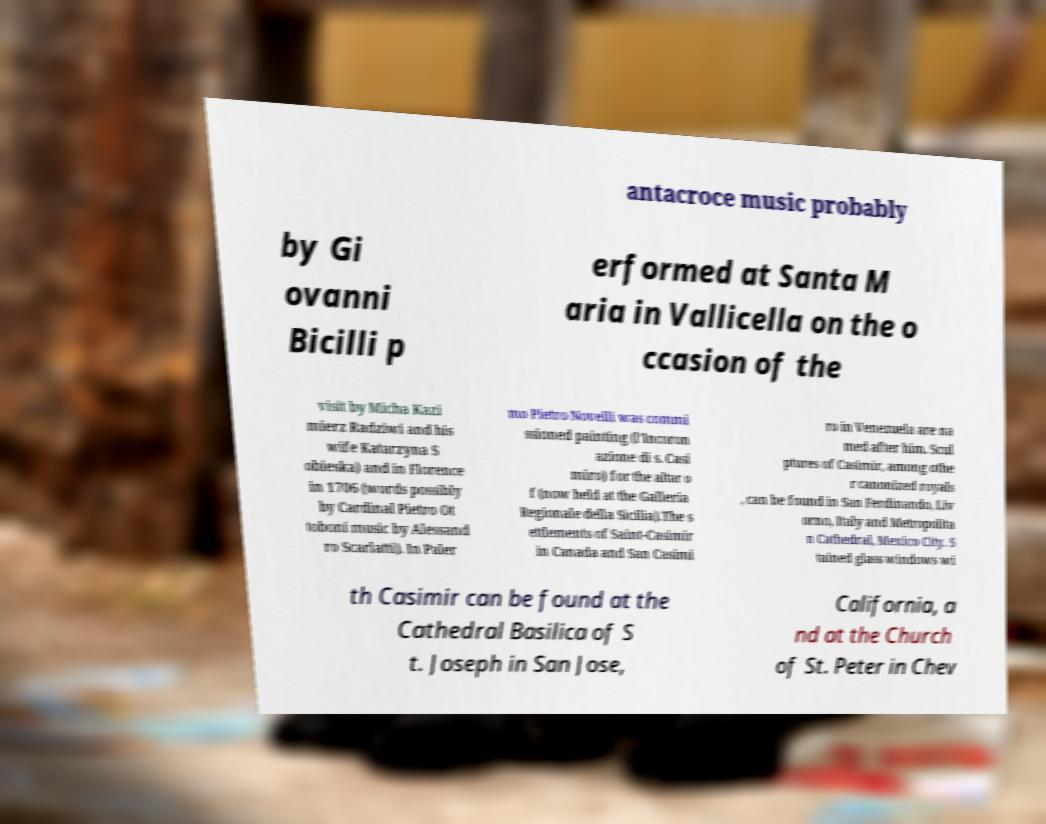Could you assist in decoding the text presented in this image and type it out clearly? antacroce music probably by Gi ovanni Bicilli p erformed at Santa M aria in Vallicella on the o ccasion of the visit by Micha Kazi mierz Radziwi and his wife Katarzyna S obieska) and in Florence in 1706 (words possibly by Cardinal Pietro Ot toboni music by Alessand ro Scarlatti). In Paler mo Pietro Novelli was commi ssioned painting (l’Incoron azione di s. Casi miro) for the altar o f (now held at the Galleria Regionale della Sicilia).The s ettlements of Saint-Casimir in Canada and San Casimi ro in Venezuela are na med after him. Scul ptures of Casimir, among othe r canonized royals , can be found in San Ferdinando, Liv orno, Italy and Metropolita n Cathedral, Mexico City. S tained glass windows wi th Casimir can be found at the Cathedral Basilica of S t. Joseph in San Jose, California, a nd at the Church of St. Peter in Chev 